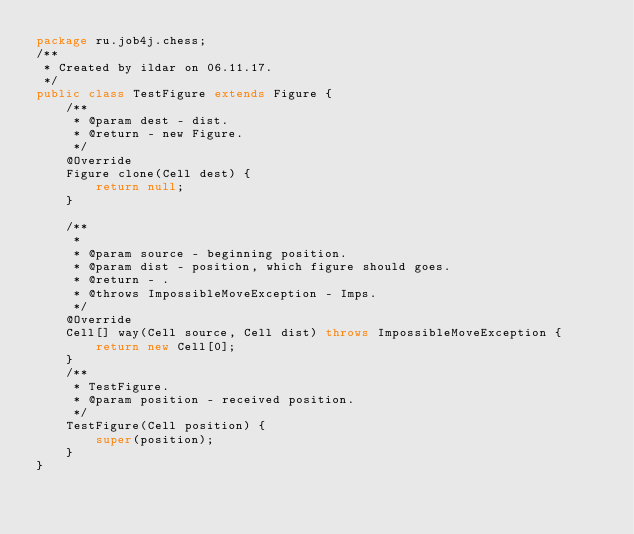<code> <loc_0><loc_0><loc_500><loc_500><_Java_>package ru.job4j.chess;
/**
 * Created by ildar on 06.11.17.
 */
public class TestFigure extends Figure {
    /**
     * @param dest - dist.
     * @return - new Figure.
     */
    @Override
    Figure clone(Cell dest) {
        return null;
    }

    /**
     *
     * @param source - beginning position.
     * @param dist - position, which figure should goes.
     * @return - .
     * @throws ImpossibleMoveException - Imps.
     */
    @Override
    Cell[] way(Cell source, Cell dist) throws ImpossibleMoveException {
        return new Cell[0];
    }
    /**
     * TestFigure.
     * @param position - received position.
     */
    TestFigure(Cell position) {
        super(position);
    }
}
</code> 